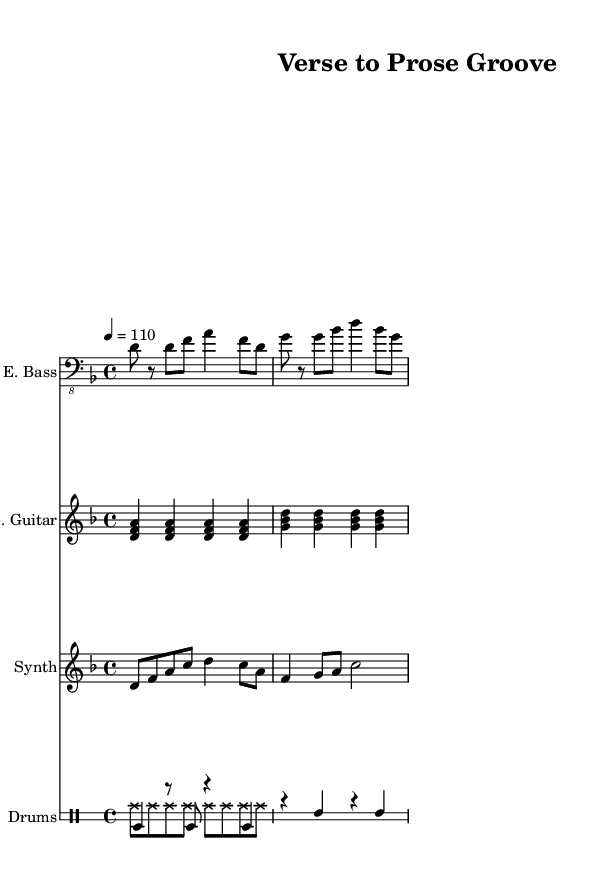What is the key signature of this music? The key signature shows two flats, which indicates that it is in D minor.
Answer: D minor What is the time signature of this music? The time signature is indicated at the beginning, showing a 4 over 4, which signifies that there are four beats in each measure.
Answer: 4/4 What is the tempo marking for this piece? The tempo marking is indicated as "4 = 110," meaning there are 110 beats per minute.
Answer: 110 How many measures does the electric guitar part contain in this excerpt? By counting the distinct groupings, the electric guitar part contains eight measures in total.
Answer: 8 measures Which instrument plays a synthesizer part in this music? The music explicitly lists an instrument labeled "Synth" on the staff, indicating that the synthesizer part is included.
Answer: Synth What is the pattern of the electric bass in the first measure? The electric bass starts on the note D and alternates between rests and notes that create a rhythmic pattern; specifically, it plays a D followed by F and A.
Answer: D, F, A How do the rhythmic patterns of the drums differ? The drums consist of pitched patterns followed by unpitched patterns. The pitched section features bass drums and snares, while the unpitched section is consistently high hats.
Answer: Pitched and unpitched 